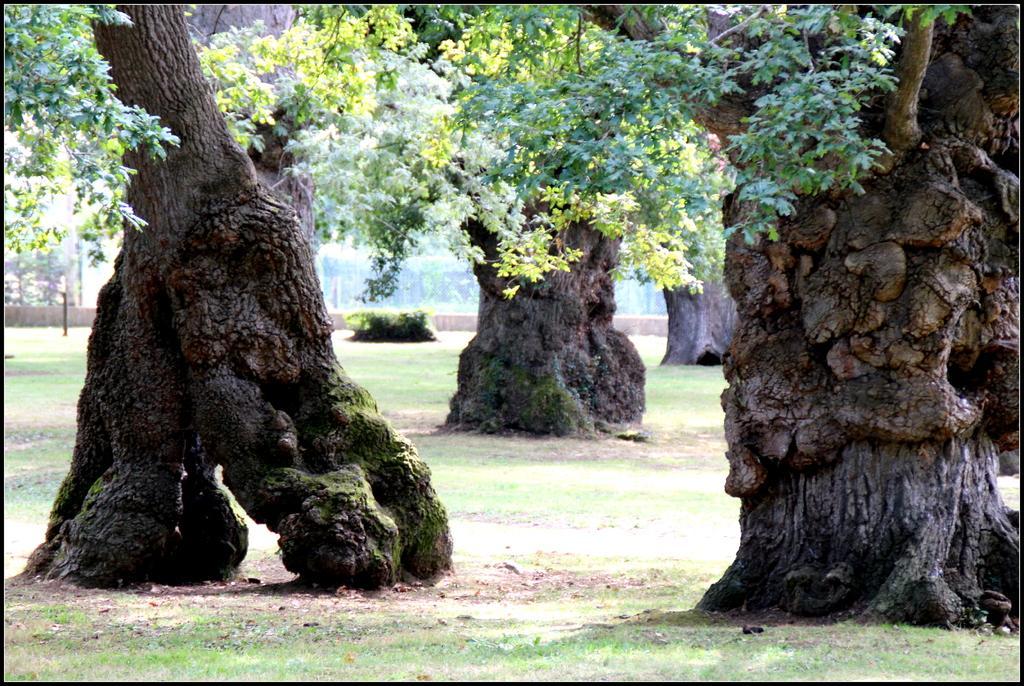Could you give a brief overview of what you see in this image? Here we can see trees on the ground,grass,plants and some other items. 